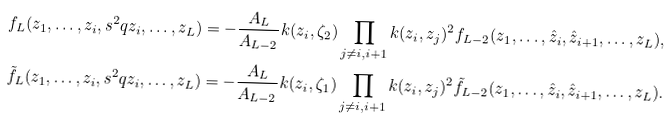Convert formula to latex. <formula><loc_0><loc_0><loc_500><loc_500>f _ { L } ( z _ { 1 } , \dots , z _ { i } , s ^ { 2 } q z _ { i } , \dots , z _ { L } ) & = - \frac { A _ { L } } { A _ { L - 2 } } k ( z _ { i } , \zeta _ { 2 } ) \prod _ { j \neq i , i + 1 } k ( z _ { i } , z _ { j } ) ^ { 2 } f _ { L - 2 } ( z _ { 1 } , \dots , \hat { z } _ { i } , \hat { z } _ { i + 1 } , \dots , z _ { L } ) , \\ \tilde { f } _ { L } ( z _ { 1 } , \dots , z _ { i } , s ^ { 2 } q z _ { i } , \dots , z _ { L } ) & = - \frac { A _ { L } } { A _ { L - 2 } } k ( z _ { i } , \zeta _ { 1 } ) \prod _ { j \neq i , i + 1 } k ( z _ { i } , z _ { j } ) ^ { 2 } \tilde { f } _ { L - 2 } ( z _ { 1 } , \dots , \hat { z } _ { i } , \hat { z } _ { i + 1 } , \dots , z _ { L } ) . \\</formula> 